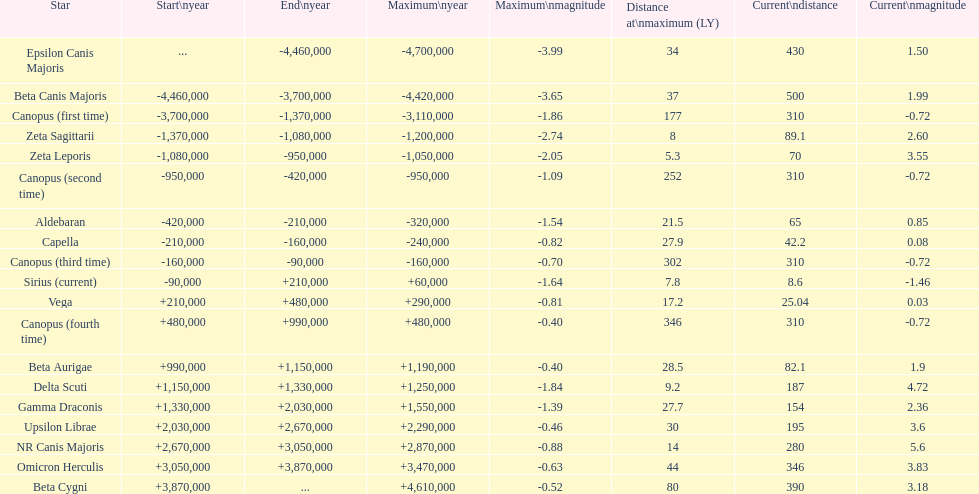How many stars possess a present magnitude of at least 11. 